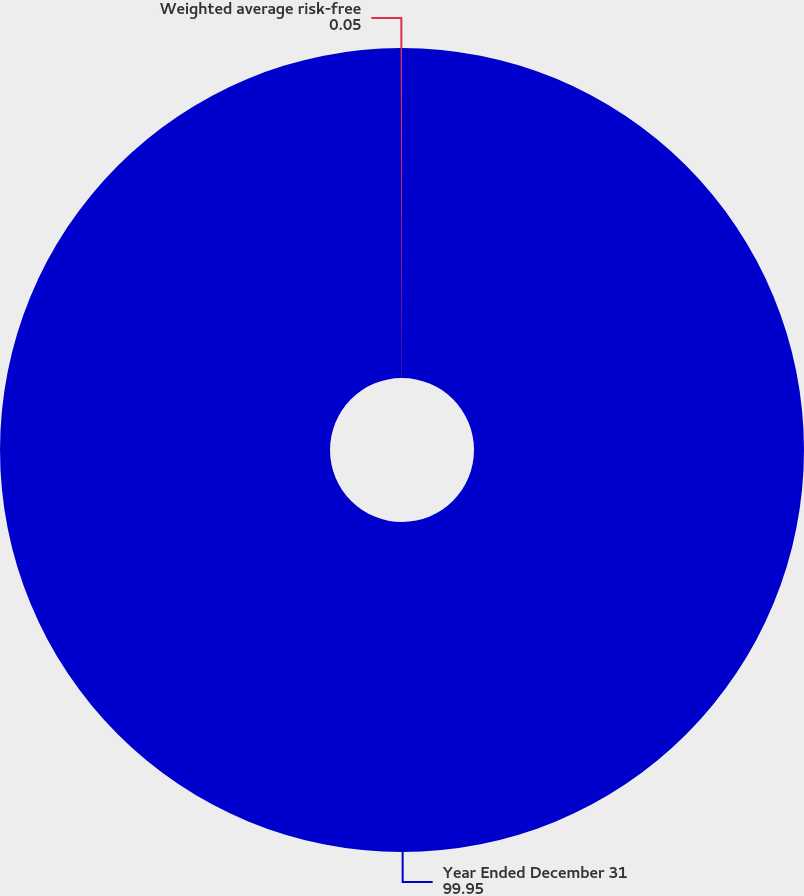<chart> <loc_0><loc_0><loc_500><loc_500><pie_chart><fcel>Year Ended December 31<fcel>Weighted average risk-free<nl><fcel>99.95%<fcel>0.05%<nl></chart> 